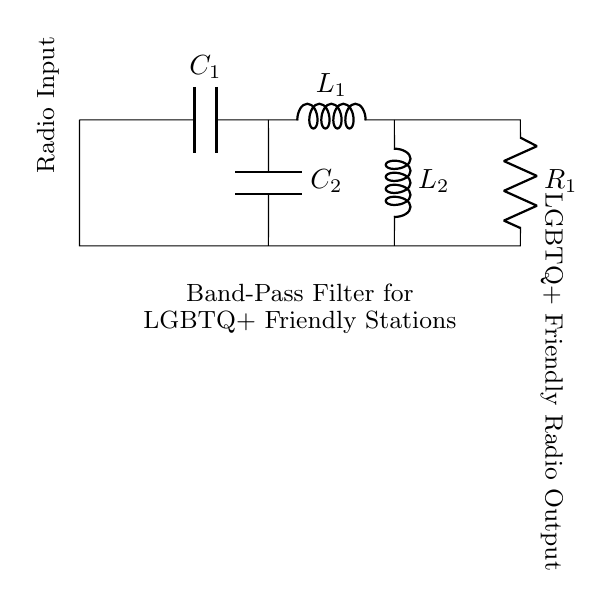what type of filter is represented in the circuit? The circuit is a band-pass filter, which allows a specific range of frequencies to pass while attenuating frequencies outside that range. This is determined by the components of the circuit, specifically the combination of capacitors and inductors.
Answer: band-pass filter how many capacitors are in the circuit? The circuit includes two capacitors, identified as C1 and C2 in the diagram. They are specifically positioned to create the desired frequency response typical of a band-pass filter.
Answer: two what is the purpose of the resistor in the circuit? The resistor, labeled R1 in the circuit, serves to dampen the circuit's response to reduce resonance peaks and stabilize the filter's behavior, helping to enhance the overall performance.
Answer: to dampen and stabilize what components create the output for LGBTQ+ friendly stations? The output for LGBTQ+ friendly stations is taken from the combination of capacitors C1 and C2, and the inductors L1 and L2, which together form the band-pass filter allowing specific radio frequencies to pass.
Answer: C1, C2, L1, L2 why are both inductors included in the design? Both inductors are essential for determining the filter's frequency characteristics. They work in conjunction with the capacitors to set the center frequency of the band-pass filter, allowing only a specific range of frequencies to be passed to the output.
Answer: to set center frequency which part of the circuit is the radio input? The radio input is located at the left side of the circuit diagram, indicated by a short line leading into the circuit from the left. This is the point where the external radio signal enters the filter for processing.
Answer: left side 